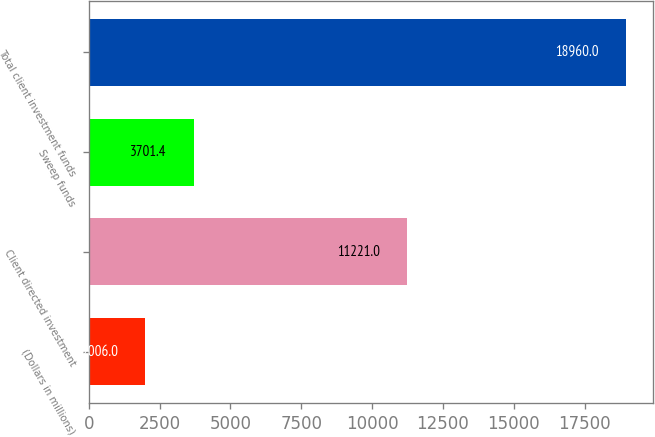<chart> <loc_0><loc_0><loc_500><loc_500><bar_chart><fcel>(Dollars in millions)<fcel>Client directed investment<fcel>Sweep funds<fcel>Total client investment funds<nl><fcel>2006<fcel>11221<fcel>3701.4<fcel>18960<nl></chart> 